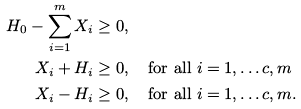Convert formula to latex. <formula><loc_0><loc_0><loc_500><loc_500>H _ { 0 } - \sum _ { i = 1 } ^ { m } X _ { i } & \geq 0 , \\ X _ { i } + H _ { i } & \geq 0 , \quad \text {for all } i = 1 , \dots c , m \\ X _ { i } - H _ { i } & \geq 0 , \quad \text {for all } i = 1 , \dots c , m .</formula> 